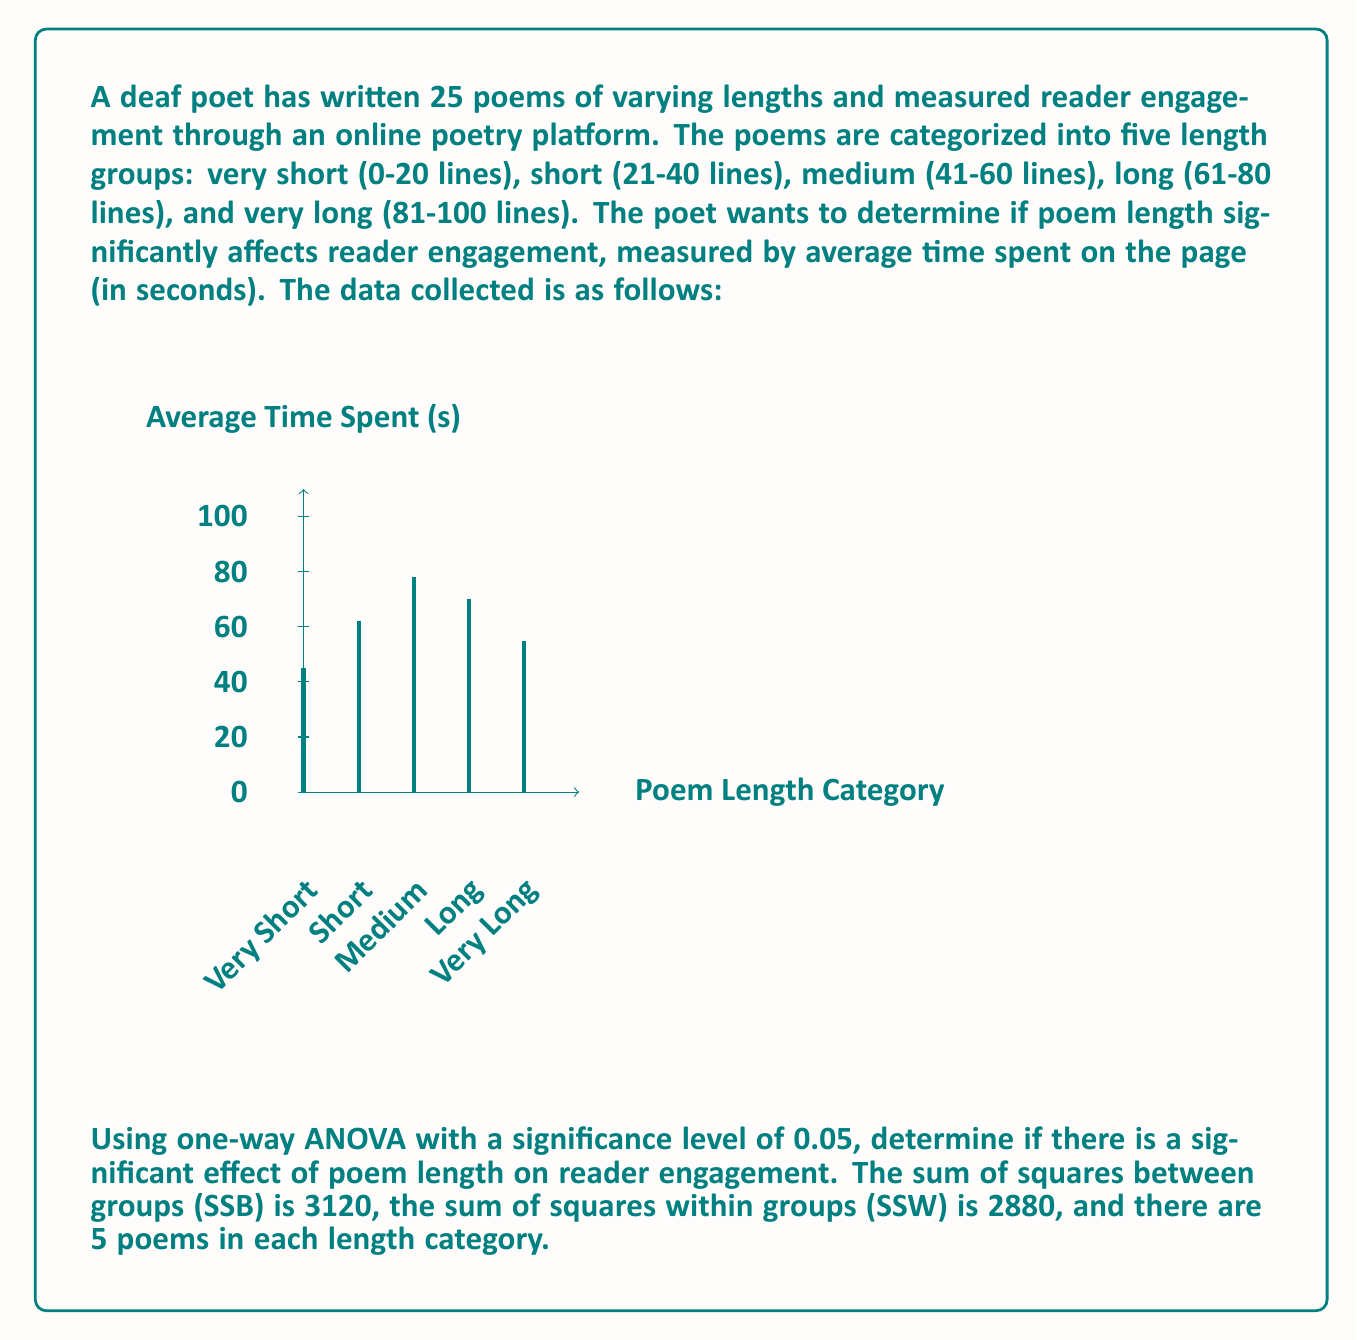Show me your answer to this math problem. Let's approach this step-by-step:

1) First, we need to calculate the degrees of freedom:
   - Between groups (dfB) = number of groups - 1 = 5 - 1 = 4
   - Within groups (dfW) = total samples - number of groups = 25 - 5 = 20
   - Total (dfT) = total samples - 1 = 25 - 1 = 24

2) Now, we can calculate the Mean Square values:
   - Mean Square Between (MSB) = SSB / dfB = 3120 / 4 = 780
   - Mean Square Within (MSW) = SSW / dfW = 2880 / 20 = 144

3) The F-statistic is calculated as:
   $$ F = \frac{MSB}{MSW} = \frac{780}{144} = 5.4167 $$

4) To determine if this F-value is significant, we need to compare it to the critical F-value.
   For α = 0.05, dfB = 4, and dfW = 20, the critical F-value is approximately 2.87 (from F-distribution tables).

5) Since our calculated F-value (5.4167) is greater than the critical F-value (2.87), we reject the null hypothesis.

6) The p-value for this F-statistic would be less than 0.05, confirming the significance of the result.
Answer: Reject null hypothesis; poem length significantly affects reader engagement (F(4,20) = 5.4167, p < 0.05). 